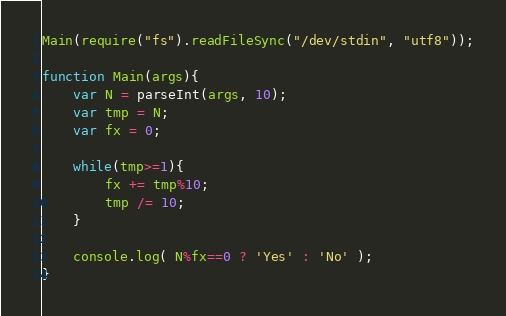<code> <loc_0><loc_0><loc_500><loc_500><_JavaScript_>Main(require("fs").readFileSync("/dev/stdin", "utf8"));

function Main(args){
    var N = parseInt(args, 10);
    var tmp = N;
    var fx = 0;

    while(tmp>=1){
        fx += tmp%10;
        tmp /= 10;
    }

    console.log( N%fx==0 ? 'Yes' : 'No' );
}</code> 